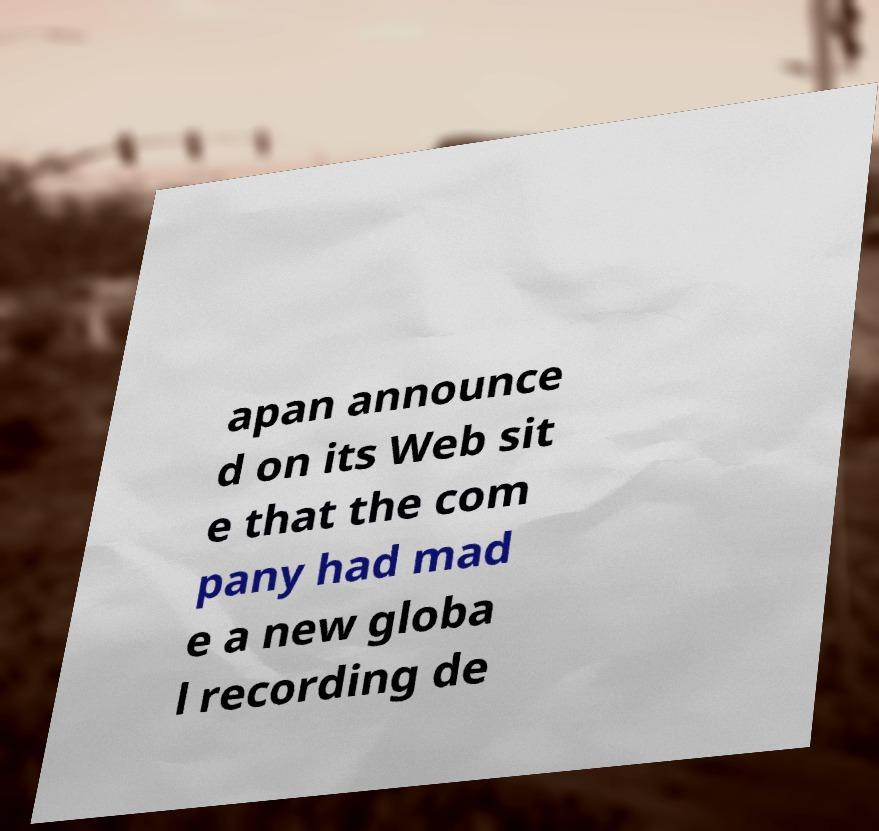For documentation purposes, I need the text within this image transcribed. Could you provide that? apan announce d on its Web sit e that the com pany had mad e a new globa l recording de 